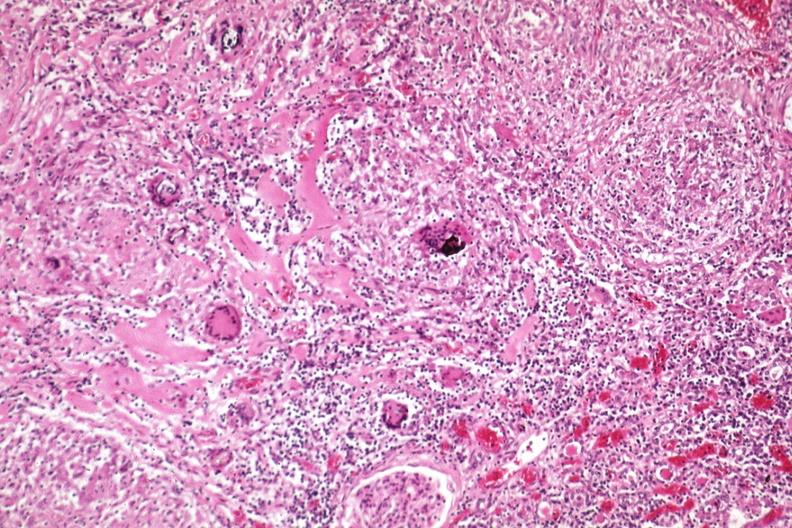s sarcoidosis present?
Answer the question using a single word or phrase. Yes 